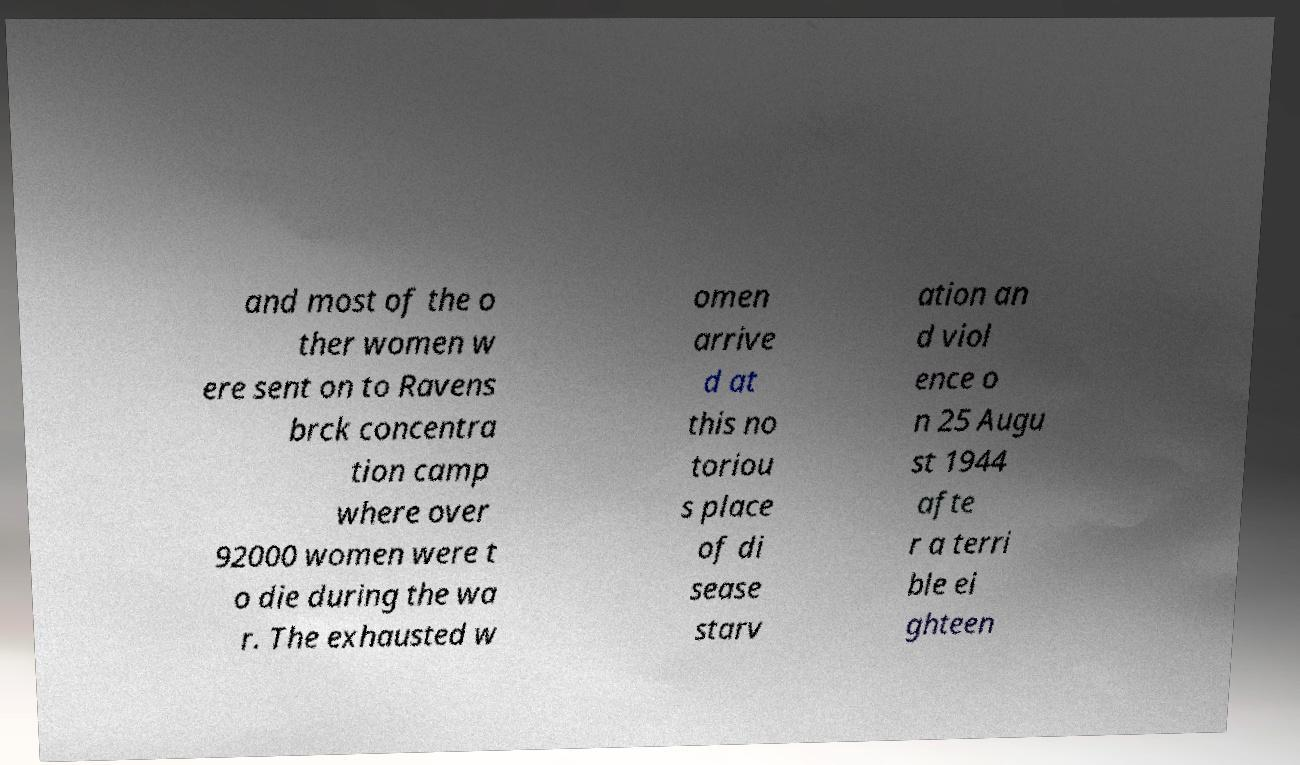Could you extract and type out the text from this image? and most of the o ther women w ere sent on to Ravens brck concentra tion camp where over 92000 women were t o die during the wa r. The exhausted w omen arrive d at this no toriou s place of di sease starv ation an d viol ence o n 25 Augu st 1944 afte r a terri ble ei ghteen 